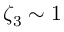<formula> <loc_0><loc_0><loc_500><loc_500>\zeta _ { 3 } \sim 1</formula> 